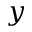<formula> <loc_0><loc_0><loc_500><loc_500>y</formula> 